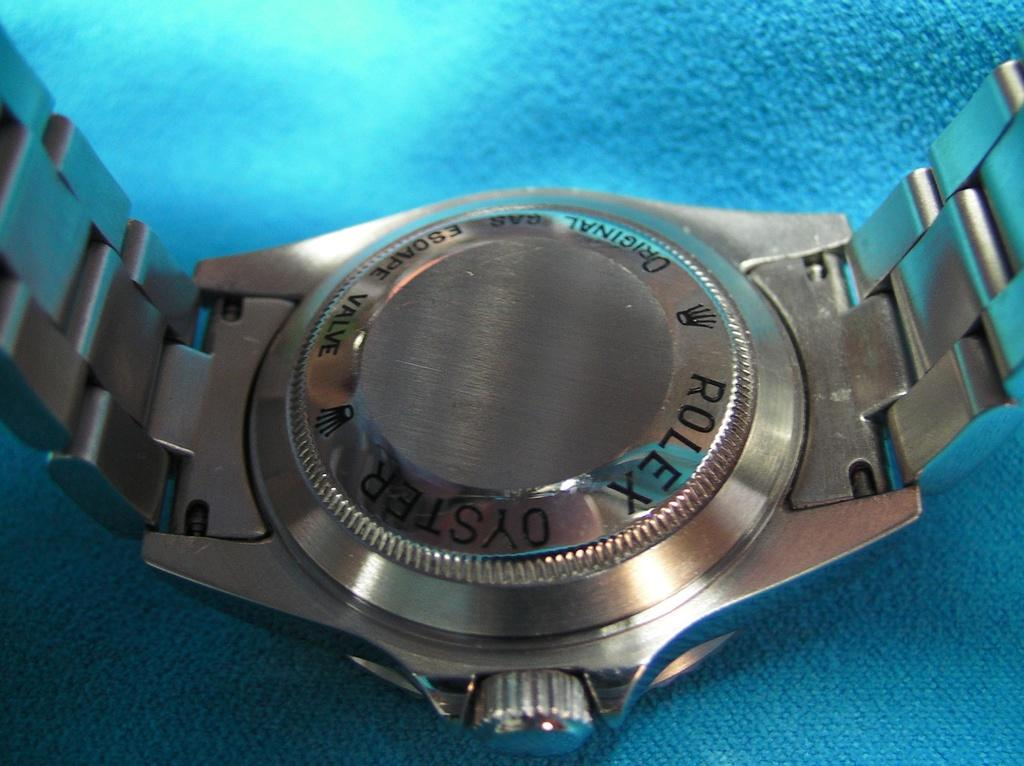Provide a one-sentence caption for the provided image. A silver Rolex watch is placed face down on a blue table. 